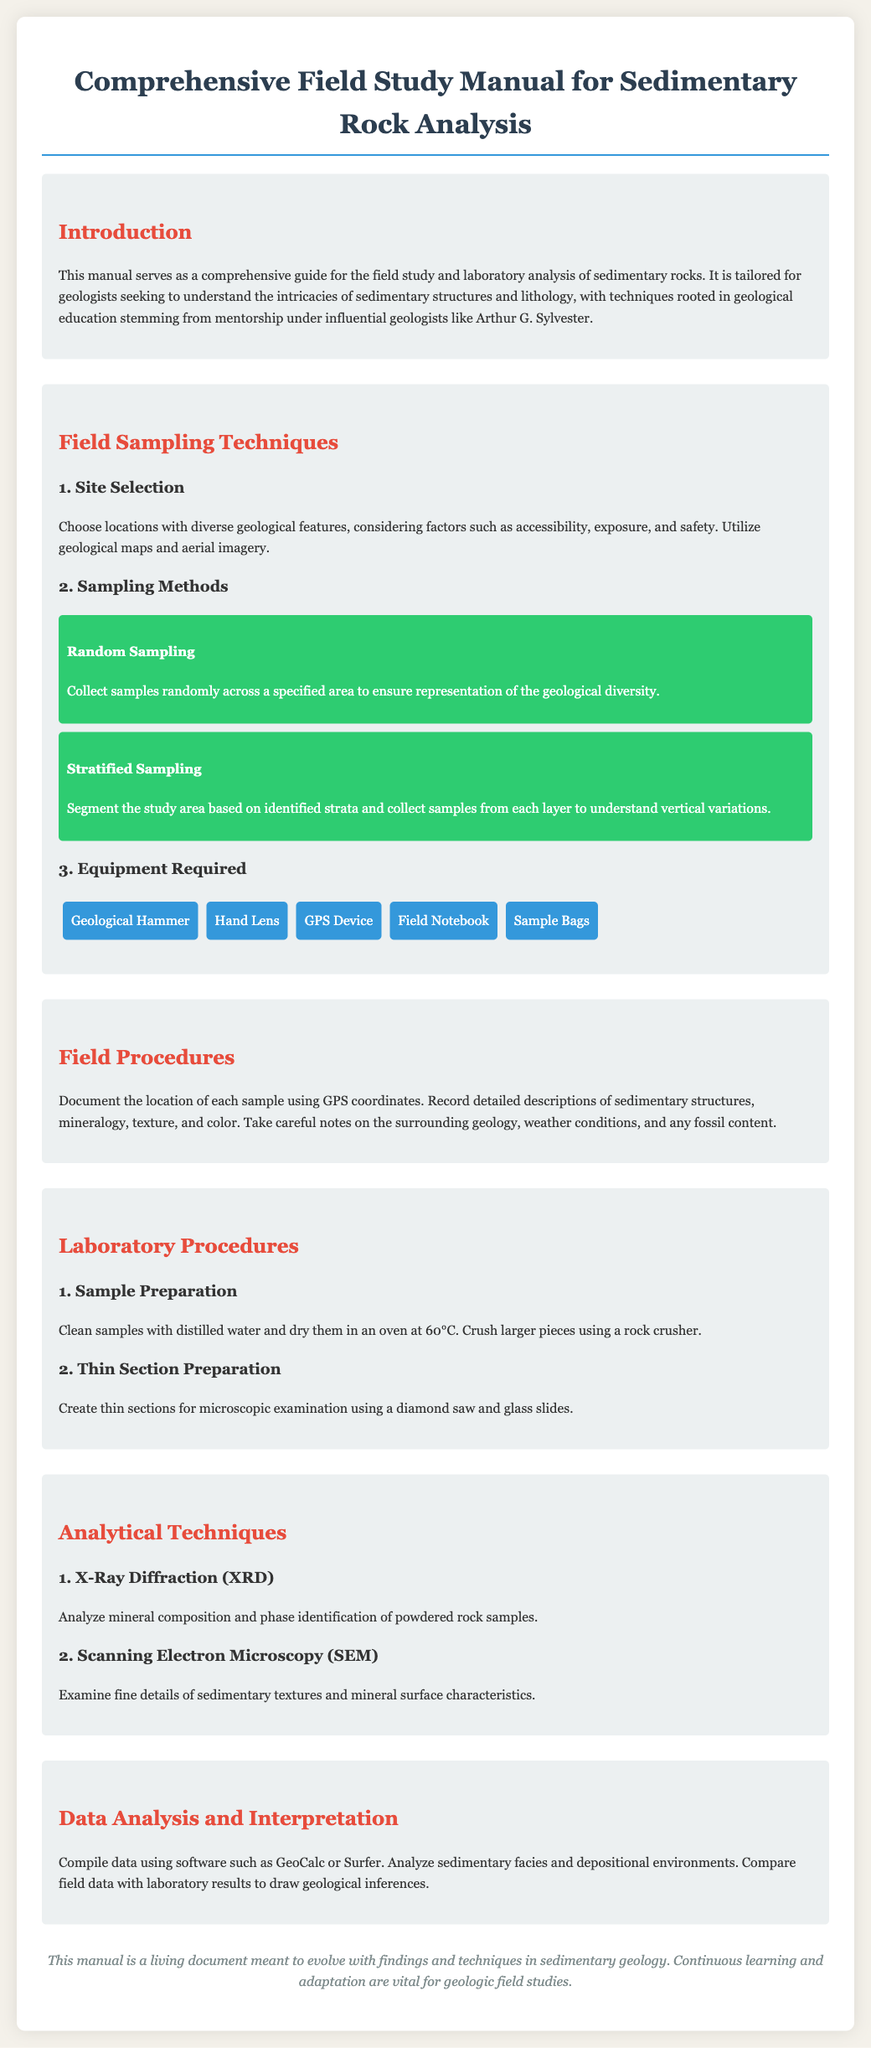What is the title of the manual? The title of the manual is clearly stated at the top of the document.
Answer: Comprehensive Field Study Manual for Sedimentary Rock Analysis What does the manual aim to guide? The introduction section outlines the purpose of the manual which is for field study and laboratory analysis.
Answer: Field study and laboratory analysis of sedimentary rocks What is one method of sampling mentioned? The section on sampling methods lists approaches for collecting samples in the field.
Answer: Random Sampling How should samples be cleaned according to the laboratory procedures? The laboratory procedures specify the cleaning method for samples in the preparation section.
Answer: Distilled water What instrument is used for creating thin sections? The manual specifies the tool needed to prepare thin sections, found in the laboratory procedures section.
Answer: Diamond saw What type of microscopy is listed in analytical techniques? Among the analytical techniques mentioned, there are specific methods for examining sedimentary textures.
Answer: Scanning Electron Microscopy Which software is suggested for data analysis? In the data analysis section, software options for compiling data are provided.
Answer: GeoCalc What temperature should samples be dried at? The laboratory procedures detail the drying temperature for samples in the sample preparation section.
Answer: 60°C What is the objective of data analysis mentioned? The document specifies the overall aim of analyzing data in the data analysis section.
Answer: Draw geological inferences 